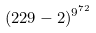Convert formula to latex. <formula><loc_0><loc_0><loc_500><loc_500>( 2 2 9 - 2 ) ^ { 9 ^ { 7 2 } }</formula> 